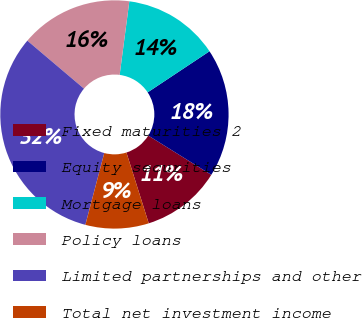Convert chart. <chart><loc_0><loc_0><loc_500><loc_500><pie_chart><fcel>Fixed maturities 2<fcel>Equity securities<fcel>Mortgage loans<fcel>Policy loans<fcel>Limited partnerships and other<fcel>Total net investment income<nl><fcel>11.27%<fcel>18.21%<fcel>13.58%<fcel>15.9%<fcel>32.09%<fcel>8.96%<nl></chart> 